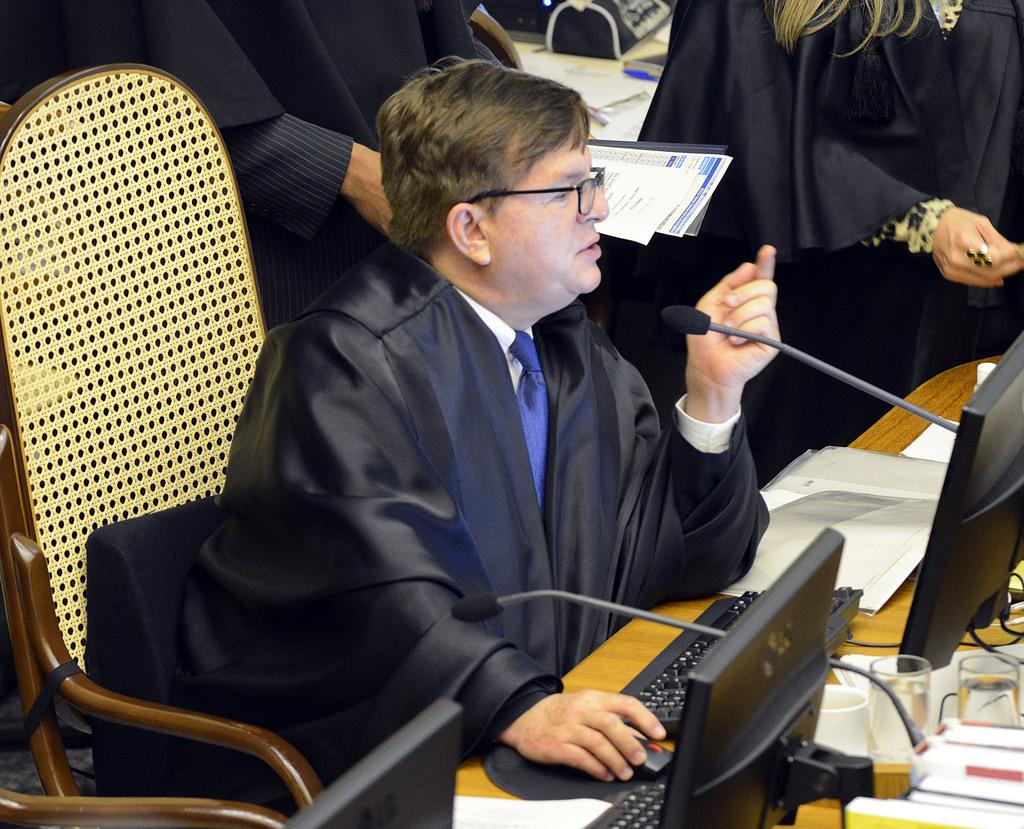Who is present in the image? There is a person in the image. What is the person wearing? The person is wearing a black coat. What is the person doing in the image? The person is sitting in a chair and operating a computer. Can you describe the people behind the person in the image? There are people behind the person in the image, but their specific actions or appearances are not mentioned in the provided facts. What type of leaf is falling on the person's eye in the image? There is no leaf or eye present in the image; it features a person sitting in a chair and operating a computer. 